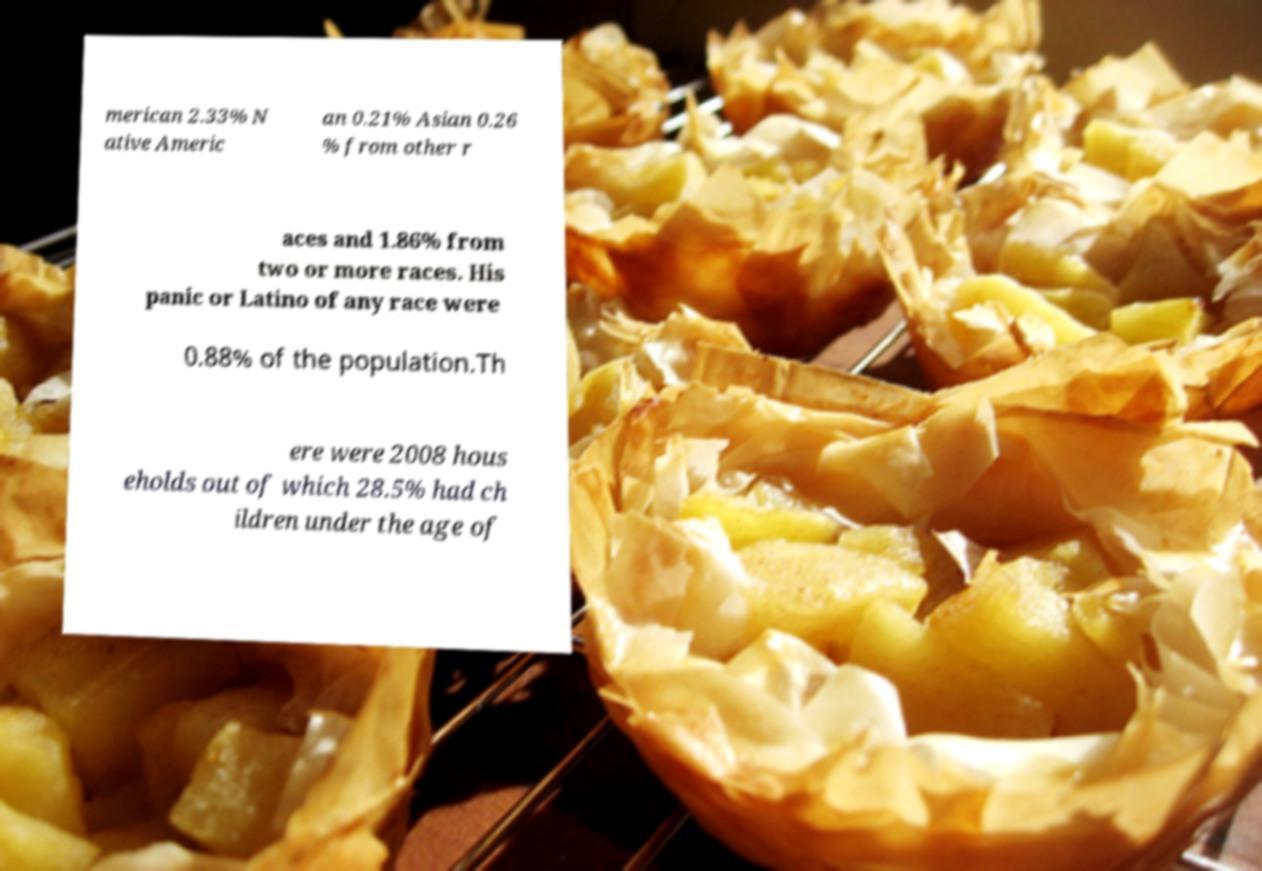Please read and relay the text visible in this image. What does it say? merican 2.33% N ative Americ an 0.21% Asian 0.26 % from other r aces and 1.86% from two or more races. His panic or Latino of any race were 0.88% of the population.Th ere were 2008 hous eholds out of which 28.5% had ch ildren under the age of 